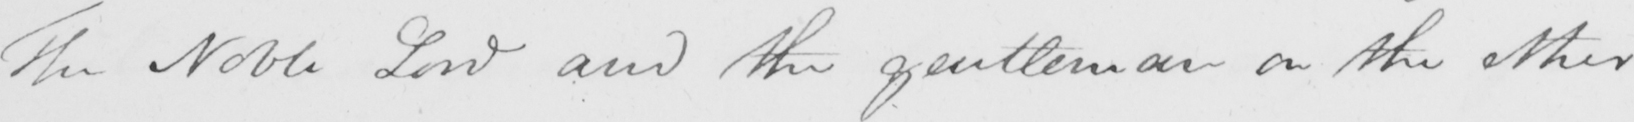What does this handwritten line say? The Nobel Lord and the gentleman on the other 